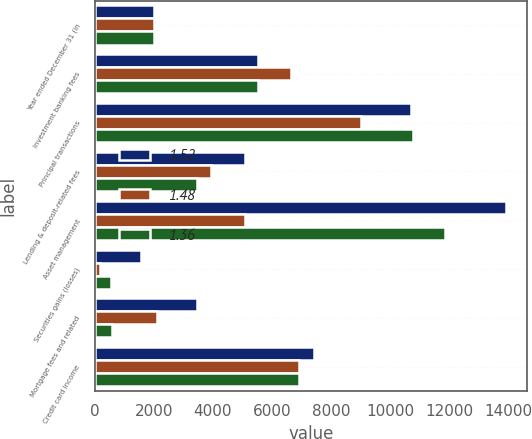<chart> <loc_0><loc_0><loc_500><loc_500><stacked_bar_chart><ecel><fcel>Year ended December 31 (in<fcel>Investment banking fees<fcel>Principal transactions<fcel>Lending & deposit-related fees<fcel>Asset management<fcel>Securities gains (losses)<fcel>Mortgage fees and related<fcel>Credit card income<nl><fcel>1.52<fcel>2008<fcel>5526<fcel>10699<fcel>5088<fcel>13943<fcel>1560<fcel>3467<fcel>7419<nl><fcel>1.48<fcel>2007<fcel>6635<fcel>9015<fcel>3938<fcel>5088<fcel>164<fcel>2118<fcel>6911<nl><fcel>1.36<fcel>2006<fcel>5520<fcel>10778<fcel>3468<fcel>11855<fcel>543<fcel>591<fcel>6913<nl></chart> 